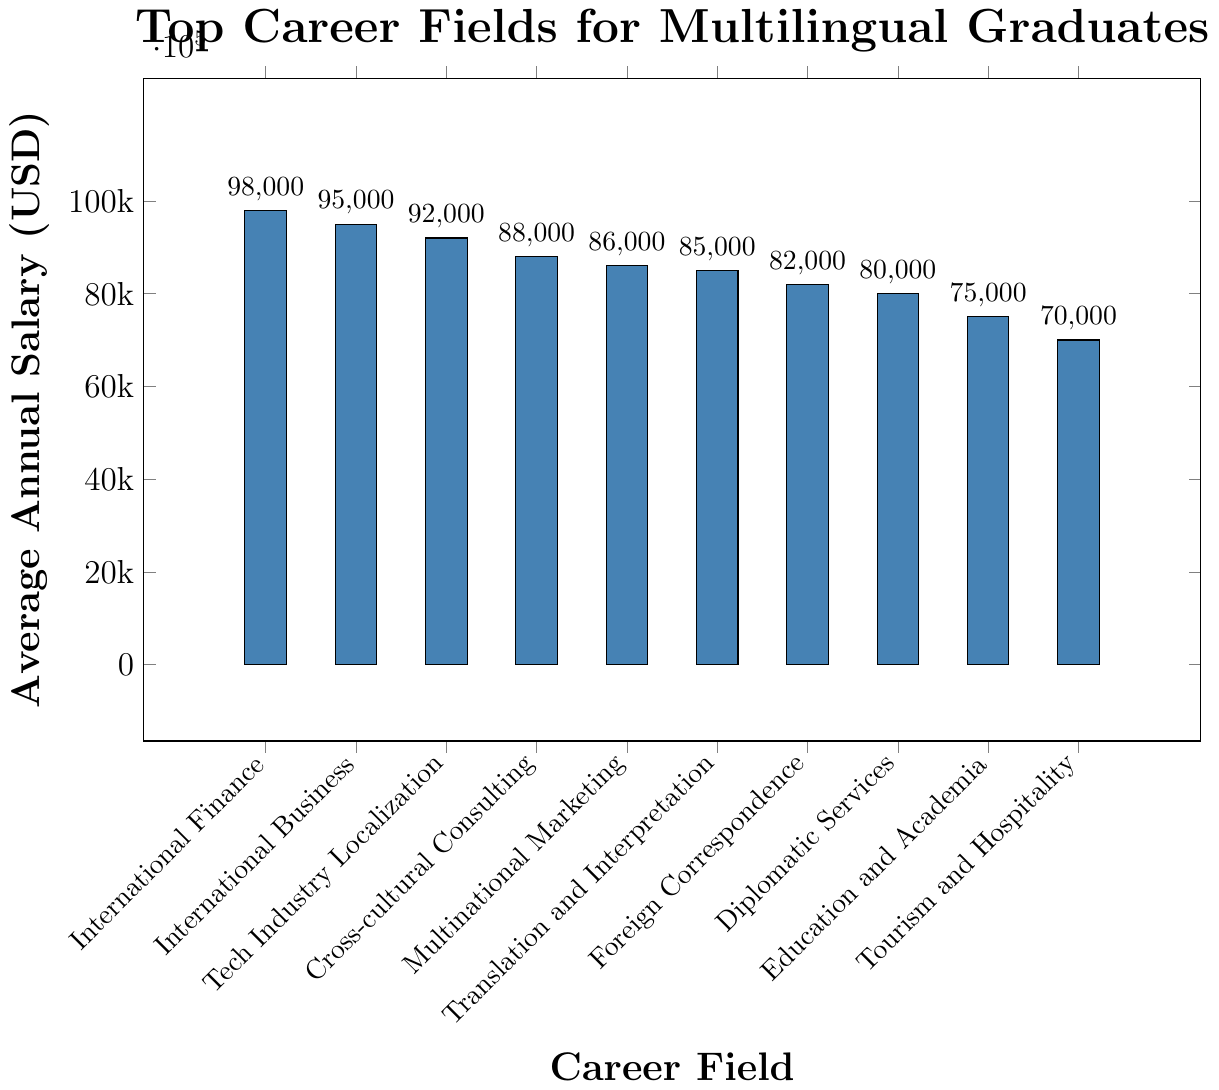What is the highest average annual salary among the career fields? The highest bar represents the career field with the top average salary. Looking at the chart, International Finance has the tallest bar.
Answer: International Finance Which career field has the lowest average annual salary? The shortest bar indicates the career field with the lowest salary. Tourism and Hospitality is represented by the shortest bar.
Answer: Tourism and Hospitality How much higher is the average annual salary of International Business compared to Education and Academia? The average salary for International Business is $95,000, and for Education and Academia, it's $75,000. Subtract the latter from the former: $95,000 - $75,000.
Answer: $20,000 What is the combined average annual salary of Tech Industry Localization and Diplomatic Services? The average salary for Tech Industry Localization is $92,000, and for Diplomatic Services, it’s $80,000. Add these two values together: $92,000 + $80,000.
Answer: $172,000 List the career fields with an average annual salary greater than $85,000. The career fields above the $85,000 mark in the bar chart are International Finance ($98,000), International Business ($95,000), Tech Industry Localization ($92,000), and Cross-cultural Consulting ($88,000).
Answer: International Finance, International Business, Tech Industry Localization, Cross-cultural Consulting Which career field has a similar average annual salary to Foreign Correspondence? The average annual salary for Foreign Correspondence is $82,000. Looking at the bar heights and their corresponding salaries, Diplomatic Services has a similar average salary at $80,000.
Answer: Diplomatic Services What is the average annual salary difference between Translation and Interpretation and Cross-cultural Consulting? The average salary for Translation and Interpretation is $85,000, and for Cross-cultural Consulting, it’s $88,000. Subtract $85,000 from $88,000.
Answer: $3,000 Rank the top three career fields by average annual salary. By observing the heights of the bars, the top three fields are International Finance ($98,000), International Business ($95,000), and Tech Industry Localization ($92,000).
Answer: International Finance, International Business, Tech Industry Localization Which career field has a higher average annual salary: Multinational Marketing or Translation and Interpretation? Looking at the bar heights, Multinational Marketing has an average annual salary of $86,000, while Translation and Interpretation is at $85,000. Comparing these two values shows that Multinational Marketing is higher.
Answer: Multinational Marketing What is the average annual salary of the top 5 highest-paying career fields? The top 5 highest-paying career fields are International Finance ($98,000), International Business ($95,000), Tech Industry Localization ($92,000), Cross-cultural Consulting ($88,000), and Multinational Marketing ($86,000). Sum these salaries and divide by 5: ($98,000 + $95,000 + $92,000 + $88,000 + $86,000) / 5.
Answer: $91,800 